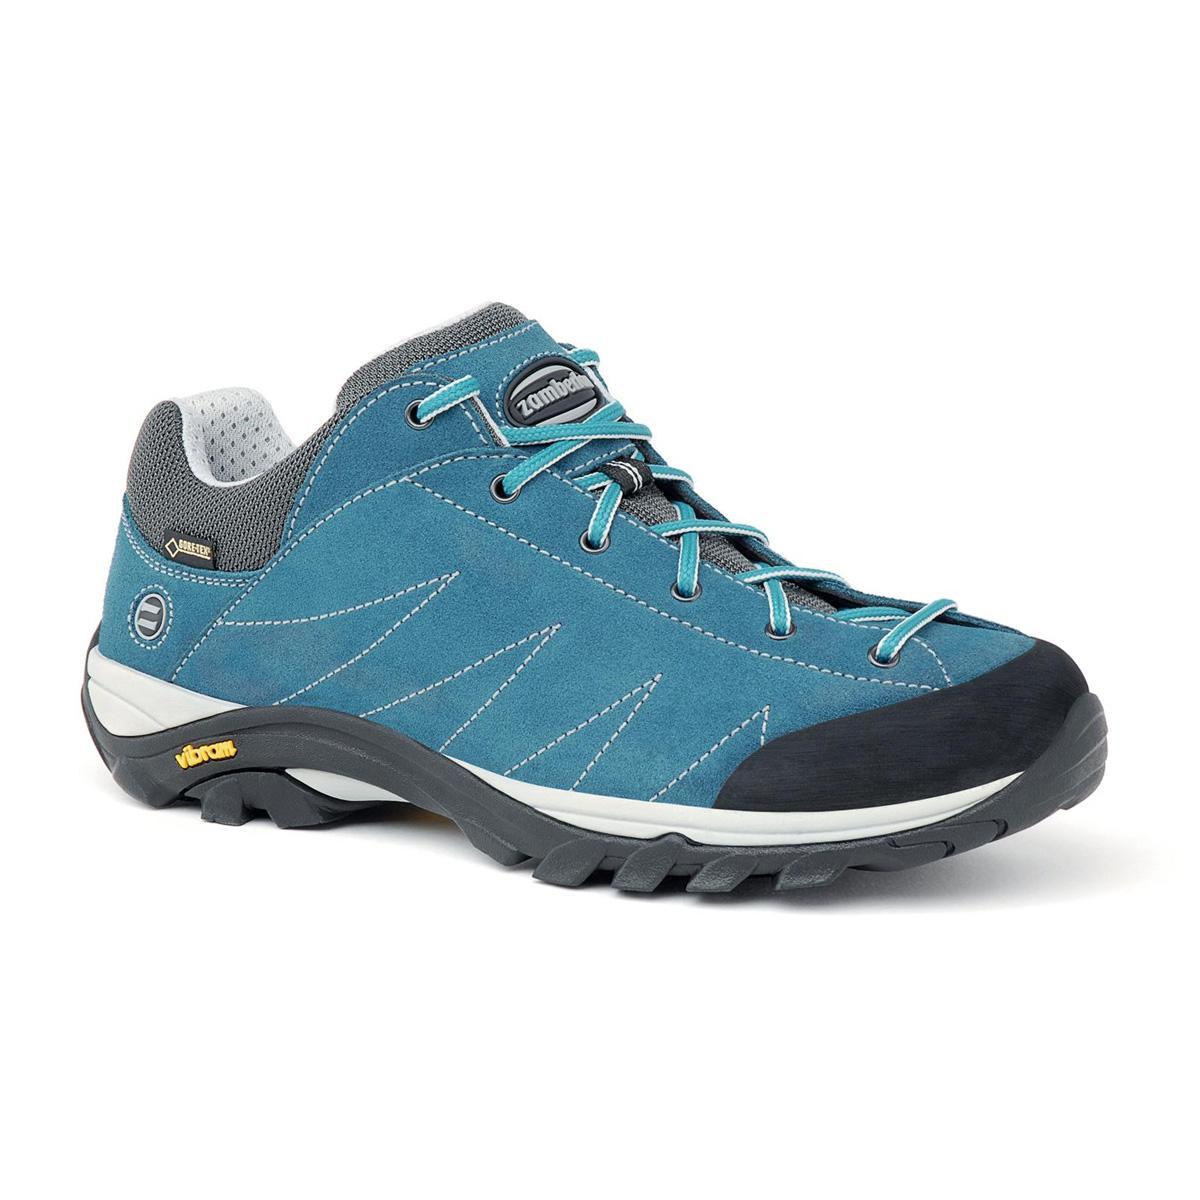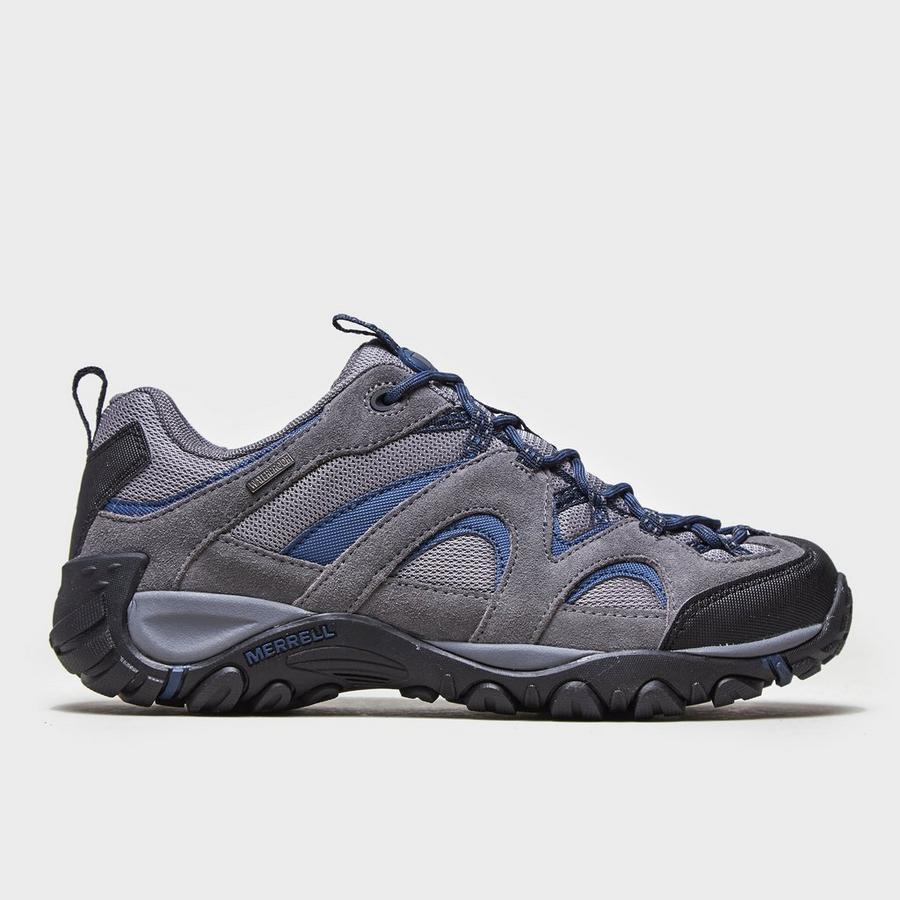The first image is the image on the left, the second image is the image on the right. Evaluate the accuracy of this statement regarding the images: "Left and right images each contain a single shoe with an athletic tread sole, one shoe has a zig-zag design element, and the shoe on the right has a loop at the heel.". Is it true? Answer yes or no. Yes. The first image is the image on the left, the second image is the image on the right. Examine the images to the left and right. Is the description "The toes of all the shoes point to the right side." accurate? Answer yes or no. Yes. 